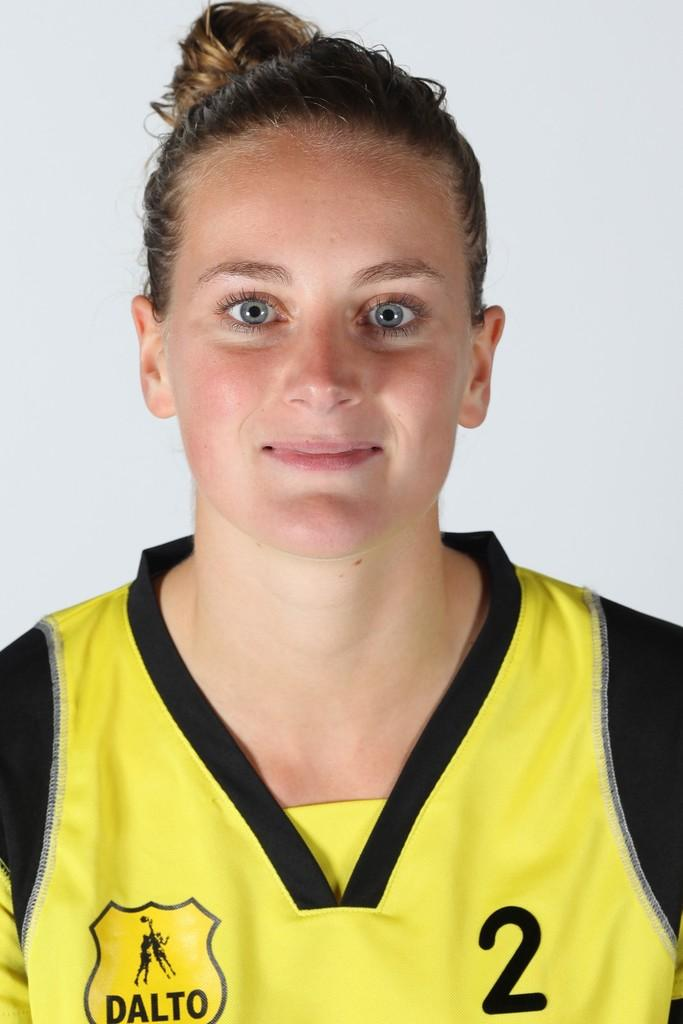<image>
Write a terse but informative summary of the picture. a person that is wearing a jersey that has the number 2 on it 